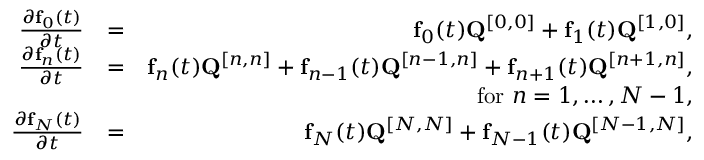Convert formula to latex. <formula><loc_0><loc_0><loc_500><loc_500>\begin{array} { r l r } { \frac { \partial { f } _ { 0 } ( t ) } { \partial t } } & { = } & { { f } _ { 0 } ( t ) { Q } ^ { [ 0 , 0 ] } + { f } _ { 1 } ( t ) { Q } ^ { [ 1 , 0 ] } , } \\ { \frac { \partial { f } _ { n } ( t ) } { \partial t } } & { = } & { { f } _ { n } ( t ) { Q } ^ { [ n , n ] } + { f } _ { n - 1 } ( t ) { Q } ^ { [ n - 1 , n ] } + { f } _ { n + 1 } ( t ) { Q } ^ { [ n + 1 , n ] } , } \\ & { \quad f o r n = 1 , \dots , N - 1 , } \\ { \frac { \partial { f } _ { N } ( t ) } { \partial t } } & { = } & { { f } _ { N } ( t ) { Q } ^ { [ N , N ] } + { f } _ { N - 1 } ( t ) { Q } ^ { [ N - 1 , N ] } , } \end{array}</formula> 